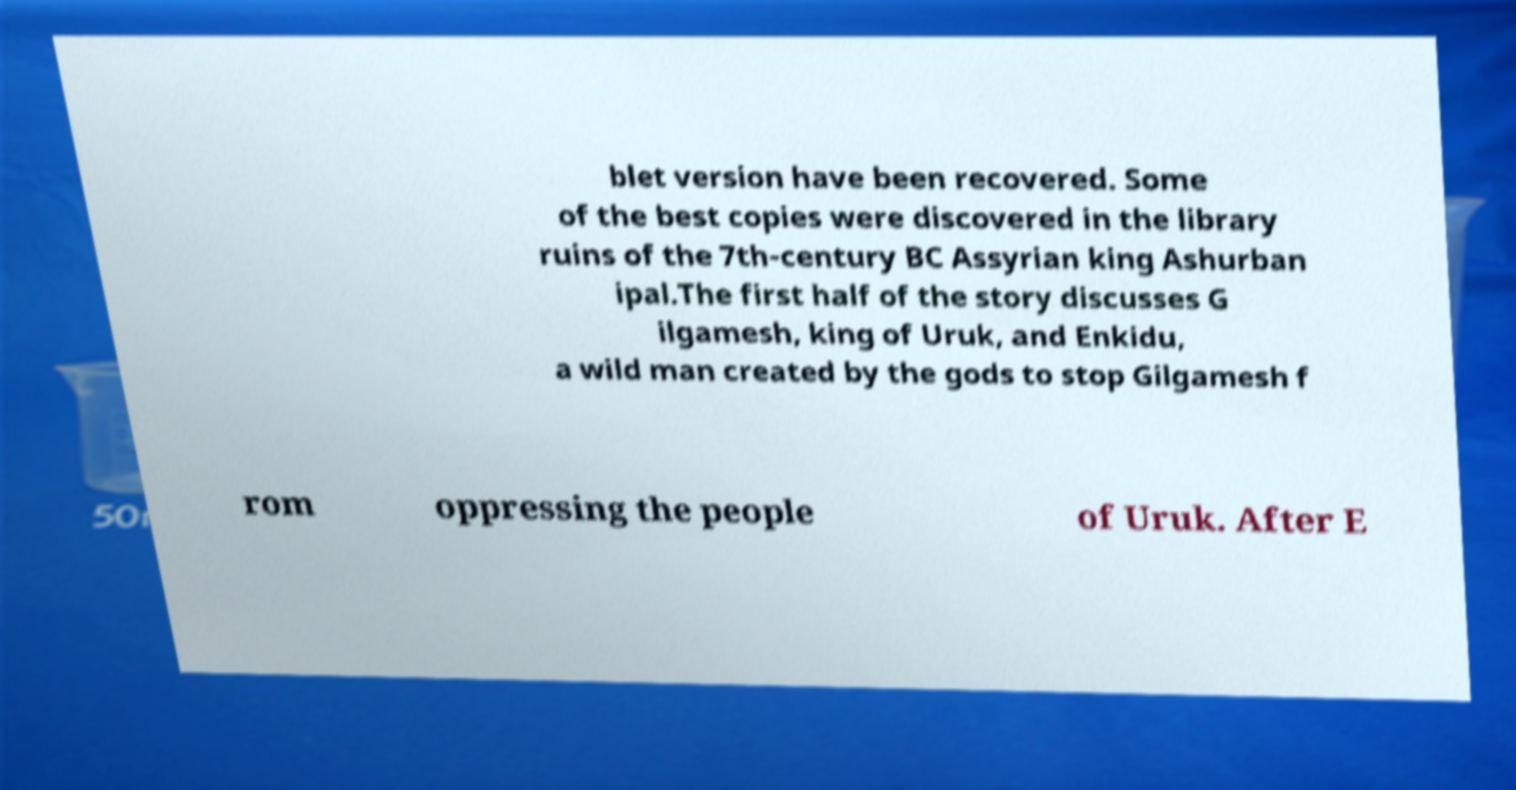For documentation purposes, I need the text within this image transcribed. Could you provide that? blet version have been recovered. Some of the best copies were discovered in the library ruins of the 7th-century BC Assyrian king Ashurban ipal.The first half of the story discusses G ilgamesh, king of Uruk, and Enkidu, a wild man created by the gods to stop Gilgamesh f rom oppressing the people of Uruk. After E 